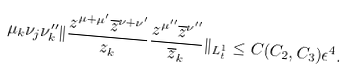Convert formula to latex. <formula><loc_0><loc_0><loc_500><loc_500>\mu _ { k } \nu _ { j } \nu ^ { \prime \prime } _ { k } \| \frac { z ^ { \mu + \mu ^ { \prime } } \overline { z } ^ { { \nu } + \nu ^ { \prime } } } { z _ { k } } \frac { z ^ { \mu ^ { \prime \prime } } \overline { z } ^ { \nu ^ { \prime \prime } } } { \overline { z } _ { k } } \| _ { L ^ { 1 } _ { t } } \leq C ( C _ { 2 } , C _ { 3 } ) \epsilon ^ { 4 } .</formula> 